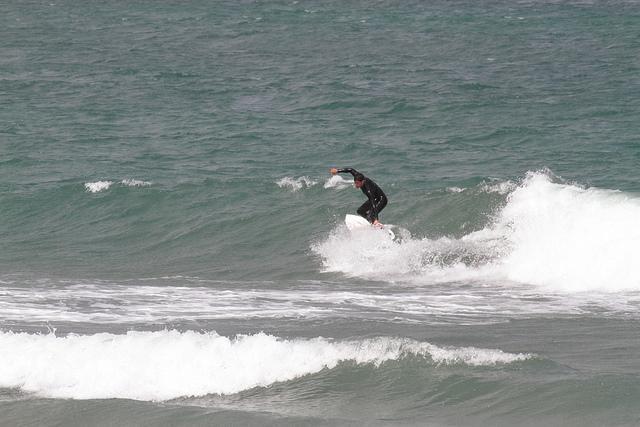How many blue drinking cups are in the picture?
Give a very brief answer. 0. 